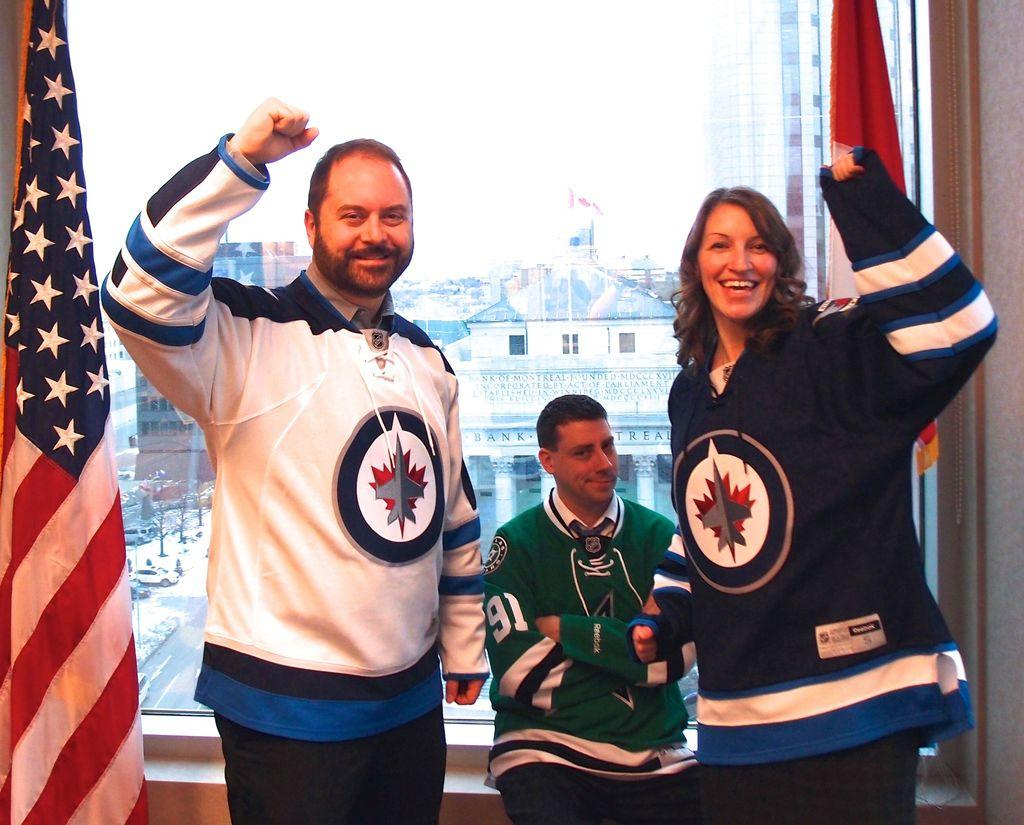<image>
Offer a succinct explanation of the picture presented. The guy in the middle has the number 91 on his sleeve. 